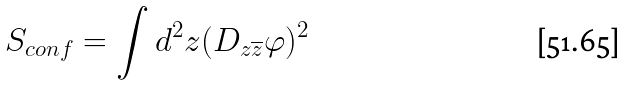<formula> <loc_0><loc_0><loc_500><loc_500>S _ { c o n f } = \int d ^ { 2 } z ( D _ { z \overline { z } } \varphi ) ^ { 2 }</formula> 